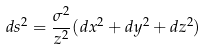<formula> <loc_0><loc_0><loc_500><loc_500>d s ^ { 2 } = \frac { \sigma ^ { 2 } } { z ^ { 2 } } ( d x ^ { 2 } + d y ^ { 2 } + d z ^ { 2 } )</formula> 